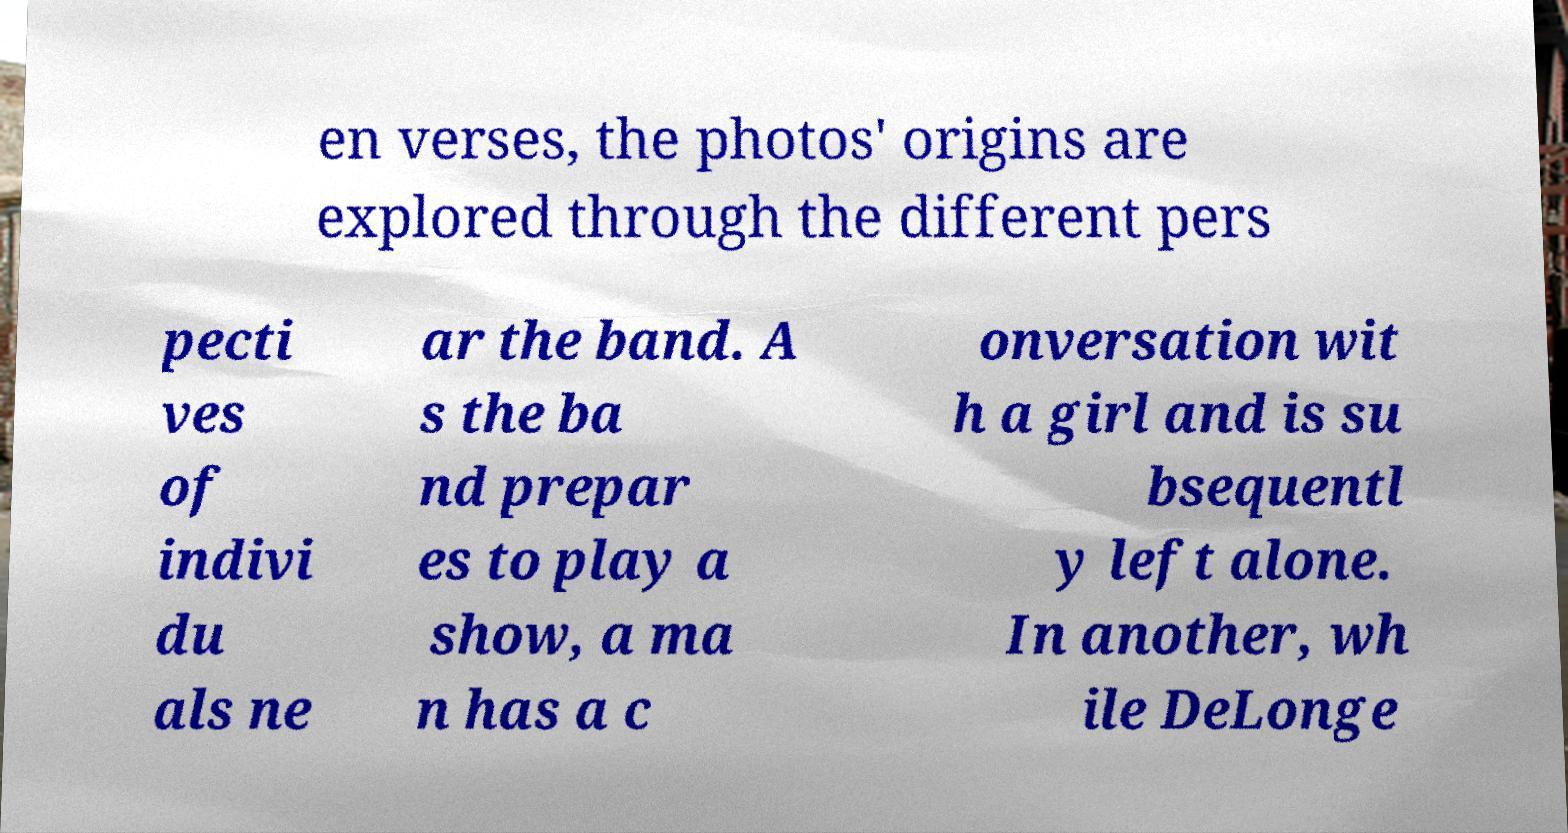Could you assist in decoding the text presented in this image and type it out clearly? en verses, the photos' origins are explored through the different pers pecti ves of indivi du als ne ar the band. A s the ba nd prepar es to play a show, a ma n has a c onversation wit h a girl and is su bsequentl y left alone. In another, wh ile DeLonge 